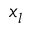Convert formula to latex. <formula><loc_0><loc_0><loc_500><loc_500>x _ { l }</formula> 